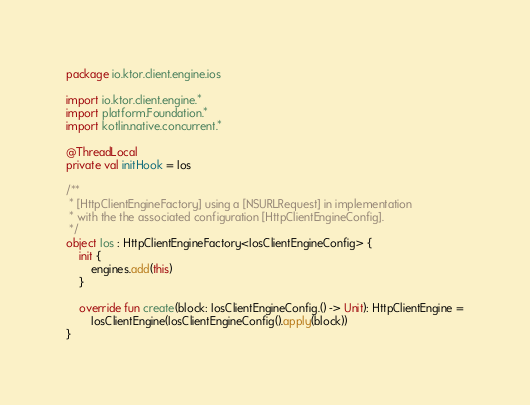<code> <loc_0><loc_0><loc_500><loc_500><_Kotlin_>package io.ktor.client.engine.ios

import io.ktor.client.engine.*
import platform.Foundation.*
import kotlin.native.concurrent.*

@ThreadLocal
private val initHook = Ios

/**
 * [HttpClientEngineFactory] using a [NSURLRequest] in implementation
 * with the the associated configuration [HttpClientEngineConfig].
 */
object Ios : HttpClientEngineFactory<IosClientEngineConfig> {
    init {
        engines.add(this)
    }

    override fun create(block: IosClientEngineConfig.() -> Unit): HttpClientEngine =
        IosClientEngine(IosClientEngineConfig().apply(block))
}
</code> 